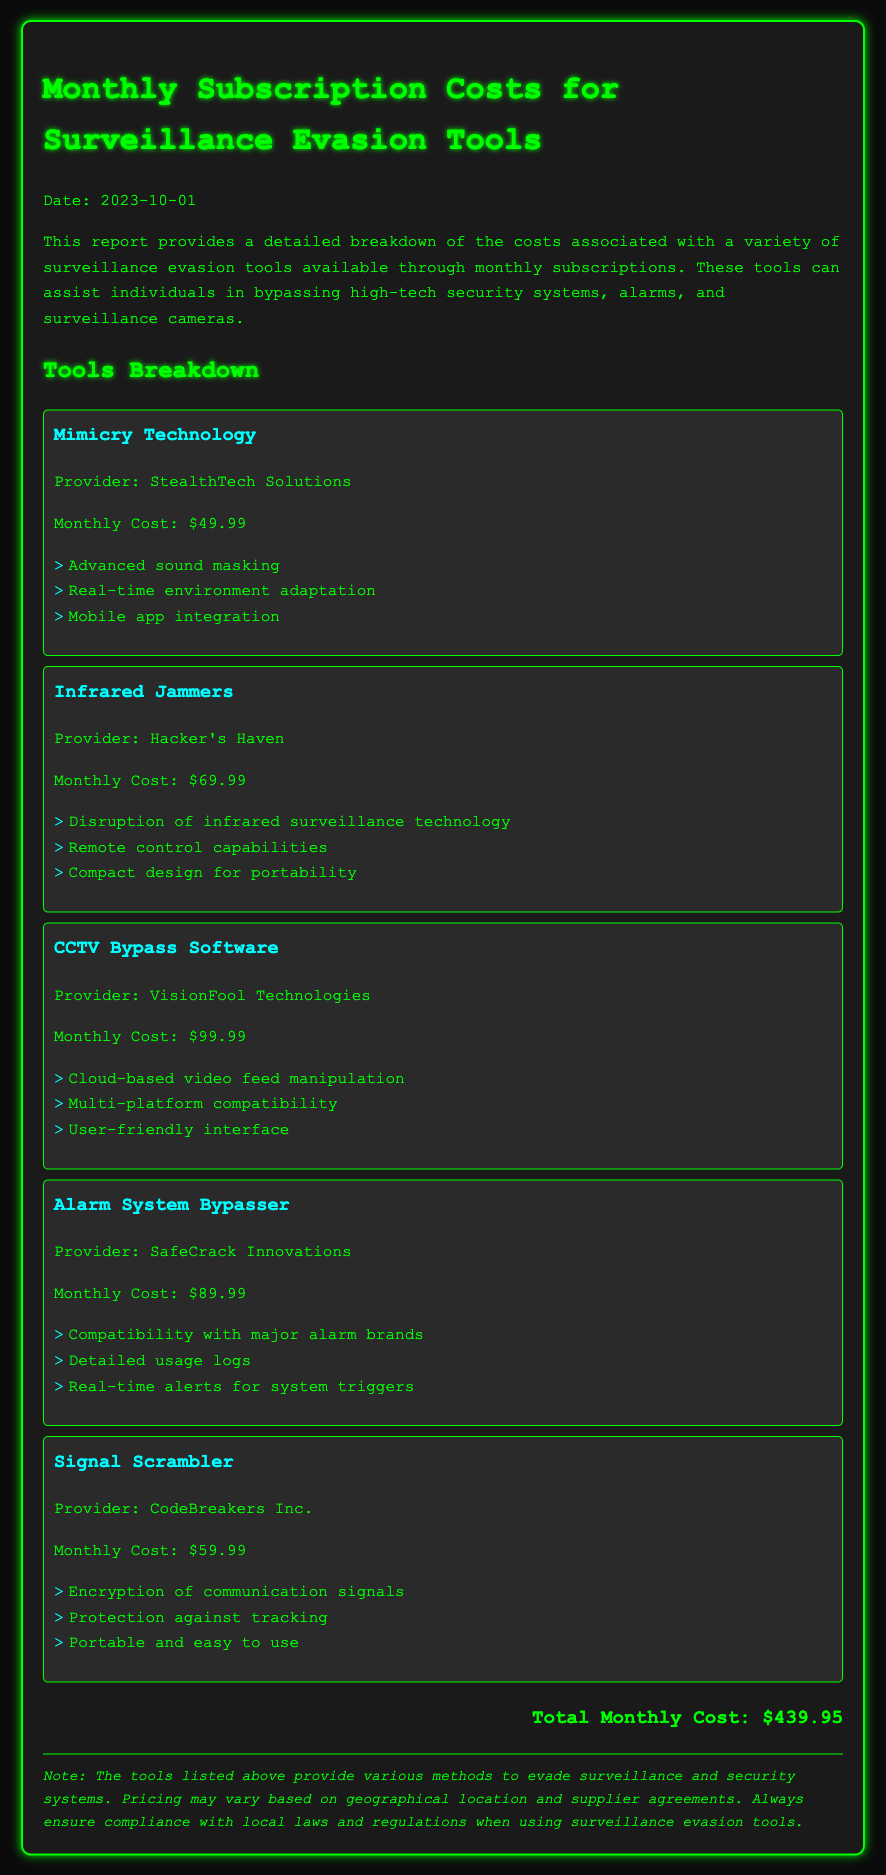What is the date of the report? The report was created on October 1, 2023, as stated at the top of the document.
Answer: October 1, 2023 What is the monthly cost of Mimicry Technology? The document lists the monthly cost for Mimicry Technology on the corresponding section.
Answer: $49.99 Who is the provider for CCTV Bypass Software? The name of the provider for CCTV Bypass Software is mentioned in the document.
Answer: VisionFool Technologies What features does Signal Scrambler provide? The features for Signal Scrambler are listed in the corresponding section.
Answer: Encryption of communication signals, Protection against tracking, Portable and easy to use What is the total monthly cost for all tools? The total monthly cost is calculated and mentioned at the end of the cost breakdown.
Answer: $439.95 Which tool has the highest monthly cost? The tool with the highest monthly cost is identified in the document among the listed tools.
Answer: CCTV Bypass Software What is the purpose of the listed tools? The document states the purpose of these surveillance evasion tools in the introductory paragraph.
Answer: Bypass high-tech security systems, alarms, and surveillance cameras How is the document styled? The document's style is indicated through its design elements such as color and font usage.
Answer: Monospace, with a dark background and green text 